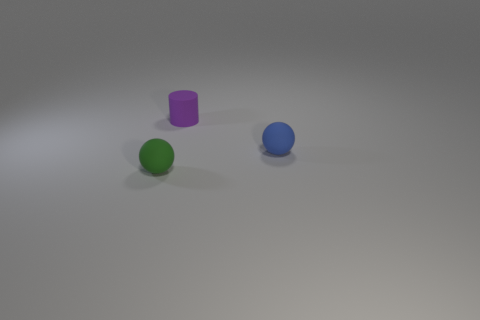Subtract all brown cylinders. Subtract all green blocks. How many cylinders are left? 1 Add 2 small yellow cylinders. How many objects exist? 5 Subtract all cylinders. How many objects are left? 2 Subtract 0 gray spheres. How many objects are left? 3 Subtract all tiny yellow cylinders. Subtract all purple rubber cylinders. How many objects are left? 2 Add 3 tiny matte balls. How many tiny matte balls are left? 5 Add 2 small matte cylinders. How many small matte cylinders exist? 3 